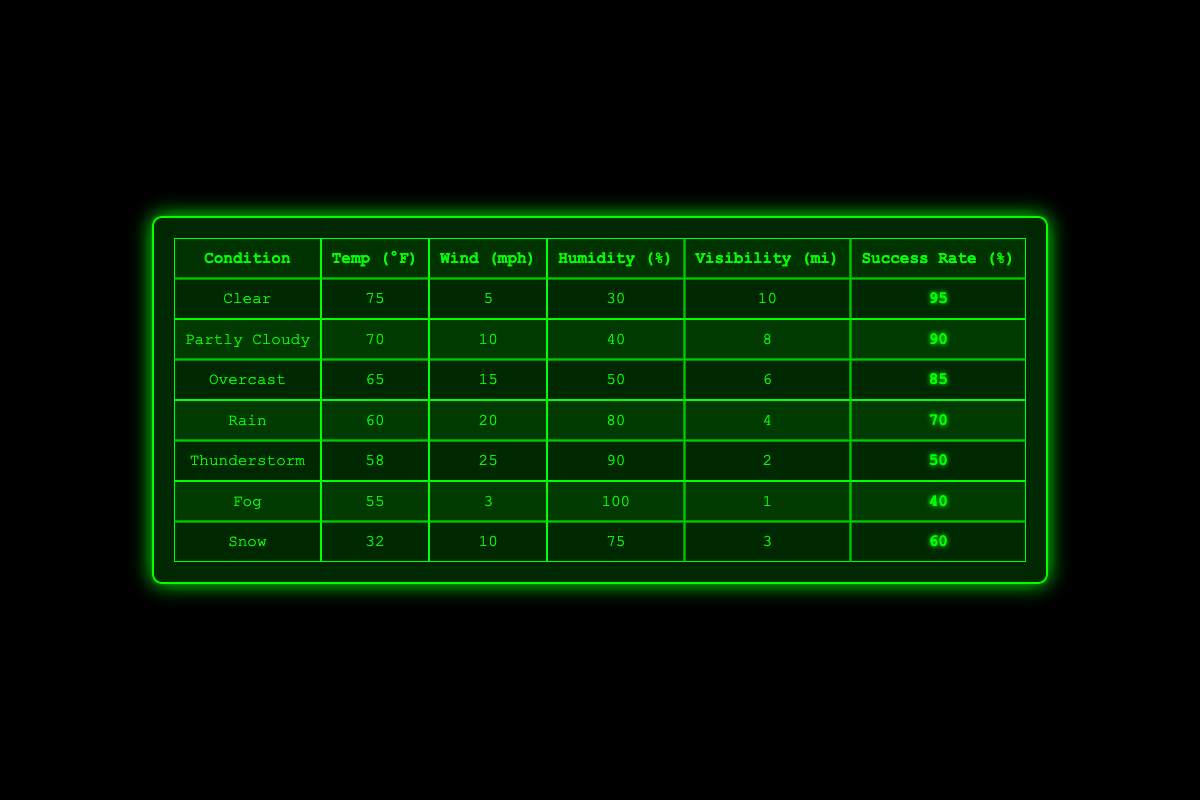What is the success rate when the weather condition is "Clear"? The table shows the "Success Rate (%)" for the "Clear" condition as 95.
Answer: 95 What is the average humidity percentage across all weather conditions? To find the average humidity, we add the percentages: (30 + 40 + 50 + 80 + 90 + 100 + 75) = 465. There are 7 data points, so the average is 465 / 7 = 66.43.
Answer: 66.43 Is the success rate higher in "Partly Cloudy" than in "Overcast"? The success rate for "Partly Cloudy" is 90, and for "Overcast," it is 85. Since 90 > 85, the statement is true.
Answer: Yes What is the maximum wind speed listed in the table, and which weather condition does it correspond to? Looking at the "Wind (mph)" column, the maximum value is 25, which corresponds to the "Thunderstorm" condition.
Answer: 25, Thunderstorm If the temperature drops to 60°F, will the success rate be higher than it is during "Clear" conditions? The success rate at 60°F ("Rain") is 70%, while the success rate for "Clear" is 95%. Since 70% is not higher than 95%, the statement is false.
Answer: No What is the difference in success rates between "Snow" and "Fog"? The success rate for "Snow" is 60, and for "Fog," it is 40. The difference is 60 - 40 = 20.
Answer: 20 For which weather condition is the visibility the lowest, and what is that value? The "Fog" condition shows the lowest visibility at 1 mile.
Answer: Fog, 1 How does the success rate change as the humidity increases from 30% to 100%? The success rate decreases from 95% (30% humidity) down to 40% (100% humidity), showing a downward trend as humidity increases.
Answer: Decreases What can be inferred about the relationship between wind speed and success rate based on the data? As the wind speed increases, the success rate tends to decrease, showing a negative correlation between these two variables.
Answer: Negative correlation 